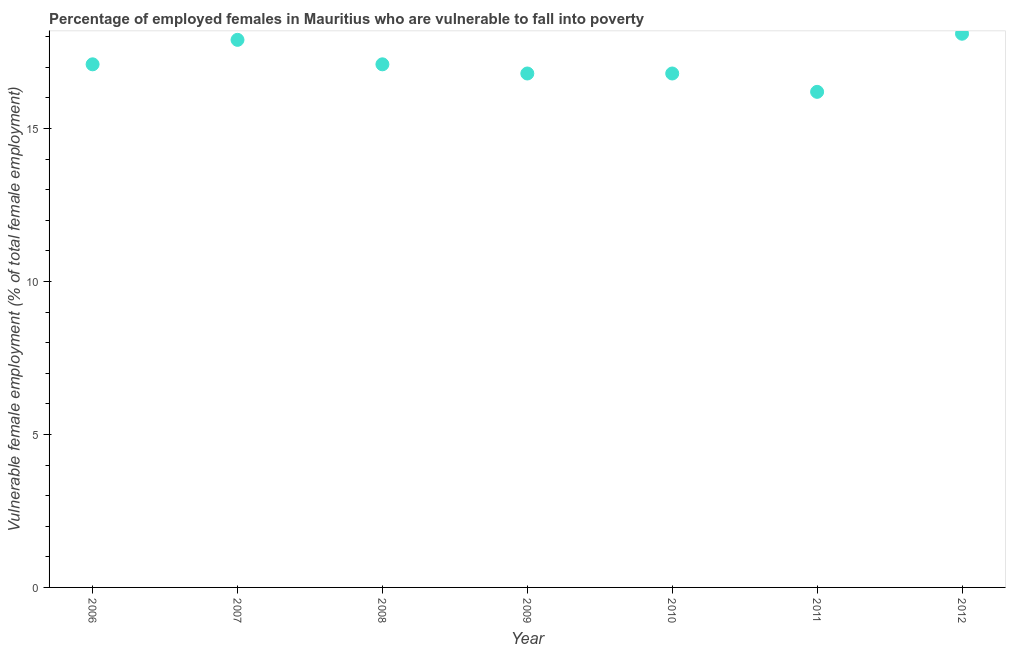What is the percentage of employed females who are vulnerable to fall into poverty in 2009?
Your answer should be compact. 16.8. Across all years, what is the maximum percentage of employed females who are vulnerable to fall into poverty?
Ensure brevity in your answer.  18.1. Across all years, what is the minimum percentage of employed females who are vulnerable to fall into poverty?
Your answer should be compact. 16.2. In which year was the percentage of employed females who are vulnerable to fall into poverty maximum?
Your response must be concise. 2012. What is the sum of the percentage of employed females who are vulnerable to fall into poverty?
Give a very brief answer. 120. What is the difference between the percentage of employed females who are vulnerable to fall into poverty in 2008 and 2011?
Offer a terse response. 0.9. What is the average percentage of employed females who are vulnerable to fall into poverty per year?
Your answer should be very brief. 17.14. What is the median percentage of employed females who are vulnerable to fall into poverty?
Your answer should be very brief. 17.1. Do a majority of the years between 2009 and 2012 (inclusive) have percentage of employed females who are vulnerable to fall into poverty greater than 11 %?
Provide a short and direct response. Yes. What is the ratio of the percentage of employed females who are vulnerable to fall into poverty in 2007 to that in 2008?
Offer a terse response. 1.05. What is the difference between the highest and the second highest percentage of employed females who are vulnerable to fall into poverty?
Offer a terse response. 0.2. What is the difference between the highest and the lowest percentage of employed females who are vulnerable to fall into poverty?
Offer a terse response. 1.9. In how many years, is the percentage of employed females who are vulnerable to fall into poverty greater than the average percentage of employed females who are vulnerable to fall into poverty taken over all years?
Offer a very short reply. 2. Does the percentage of employed females who are vulnerable to fall into poverty monotonically increase over the years?
Your response must be concise. No. What is the difference between two consecutive major ticks on the Y-axis?
Your answer should be very brief. 5. Are the values on the major ticks of Y-axis written in scientific E-notation?
Ensure brevity in your answer.  No. Does the graph contain any zero values?
Ensure brevity in your answer.  No. What is the title of the graph?
Give a very brief answer. Percentage of employed females in Mauritius who are vulnerable to fall into poverty. What is the label or title of the Y-axis?
Provide a short and direct response. Vulnerable female employment (% of total female employment). What is the Vulnerable female employment (% of total female employment) in 2006?
Offer a very short reply. 17.1. What is the Vulnerable female employment (% of total female employment) in 2007?
Offer a terse response. 17.9. What is the Vulnerable female employment (% of total female employment) in 2008?
Provide a short and direct response. 17.1. What is the Vulnerable female employment (% of total female employment) in 2009?
Offer a very short reply. 16.8. What is the Vulnerable female employment (% of total female employment) in 2010?
Keep it short and to the point. 16.8. What is the Vulnerable female employment (% of total female employment) in 2011?
Your answer should be very brief. 16.2. What is the Vulnerable female employment (% of total female employment) in 2012?
Offer a terse response. 18.1. What is the difference between the Vulnerable female employment (% of total female employment) in 2006 and 2009?
Give a very brief answer. 0.3. What is the difference between the Vulnerable female employment (% of total female employment) in 2008 and 2009?
Your answer should be compact. 0.3. What is the difference between the Vulnerable female employment (% of total female employment) in 2008 and 2011?
Keep it short and to the point. 0.9. What is the difference between the Vulnerable female employment (% of total female employment) in 2008 and 2012?
Keep it short and to the point. -1. What is the difference between the Vulnerable female employment (% of total female employment) in 2009 and 2012?
Provide a succinct answer. -1.3. What is the ratio of the Vulnerable female employment (% of total female employment) in 2006 to that in 2007?
Make the answer very short. 0.95. What is the ratio of the Vulnerable female employment (% of total female employment) in 2006 to that in 2010?
Offer a terse response. 1.02. What is the ratio of the Vulnerable female employment (% of total female employment) in 2006 to that in 2011?
Offer a very short reply. 1.06. What is the ratio of the Vulnerable female employment (% of total female employment) in 2006 to that in 2012?
Give a very brief answer. 0.94. What is the ratio of the Vulnerable female employment (% of total female employment) in 2007 to that in 2008?
Ensure brevity in your answer.  1.05. What is the ratio of the Vulnerable female employment (% of total female employment) in 2007 to that in 2009?
Your response must be concise. 1.06. What is the ratio of the Vulnerable female employment (% of total female employment) in 2007 to that in 2010?
Your response must be concise. 1.06. What is the ratio of the Vulnerable female employment (% of total female employment) in 2007 to that in 2011?
Keep it short and to the point. 1.1. What is the ratio of the Vulnerable female employment (% of total female employment) in 2007 to that in 2012?
Keep it short and to the point. 0.99. What is the ratio of the Vulnerable female employment (% of total female employment) in 2008 to that in 2010?
Provide a short and direct response. 1.02. What is the ratio of the Vulnerable female employment (% of total female employment) in 2008 to that in 2011?
Offer a terse response. 1.06. What is the ratio of the Vulnerable female employment (% of total female employment) in 2008 to that in 2012?
Your response must be concise. 0.94. What is the ratio of the Vulnerable female employment (% of total female employment) in 2009 to that in 2011?
Offer a terse response. 1.04. What is the ratio of the Vulnerable female employment (% of total female employment) in 2009 to that in 2012?
Provide a short and direct response. 0.93. What is the ratio of the Vulnerable female employment (% of total female employment) in 2010 to that in 2011?
Your response must be concise. 1.04. What is the ratio of the Vulnerable female employment (% of total female employment) in 2010 to that in 2012?
Keep it short and to the point. 0.93. What is the ratio of the Vulnerable female employment (% of total female employment) in 2011 to that in 2012?
Provide a succinct answer. 0.9. 